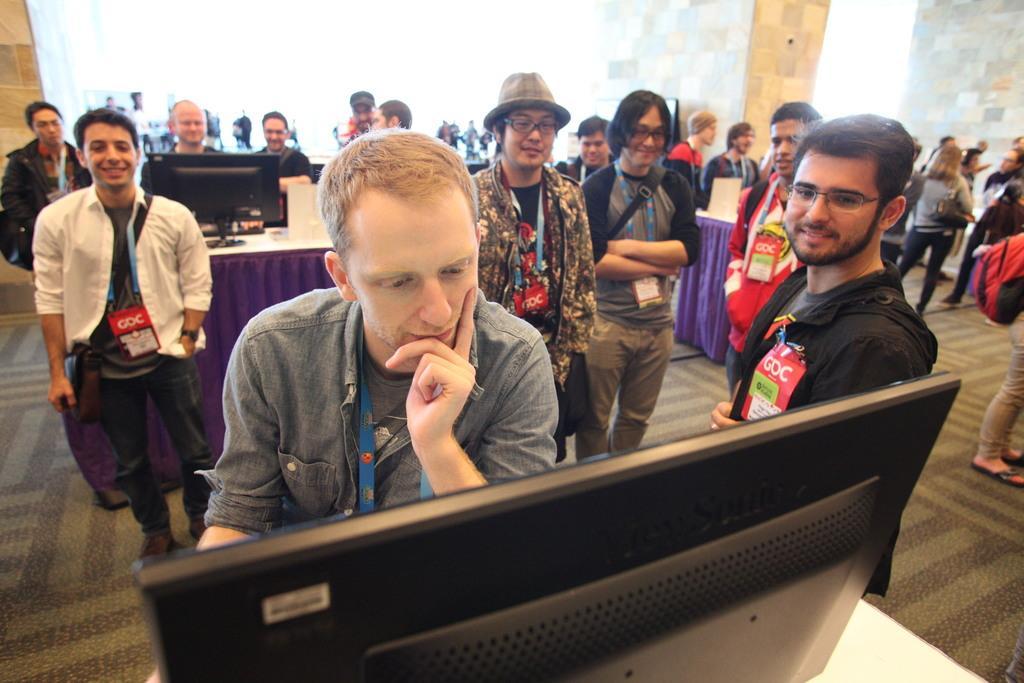In one or two sentences, can you explain what this image depicts? This image consists of many people. They are wearing ID cards. In the front, the man is standing in front of the monitor. At the bottom, there is a floor mat. In the background, there is a wall. 